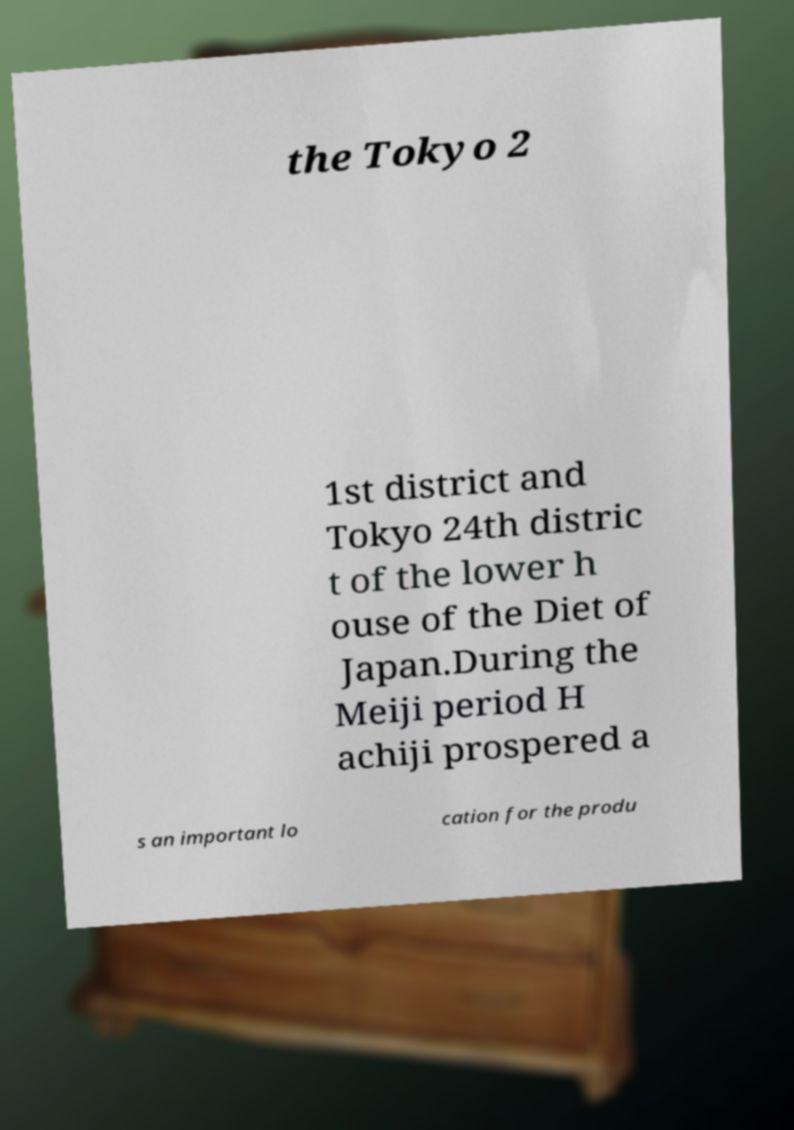Please read and relay the text visible in this image. What does it say? the Tokyo 2 1st district and Tokyo 24th distric t of the lower h ouse of the Diet of Japan.During the Meiji period H achiji prospered a s an important lo cation for the produ 